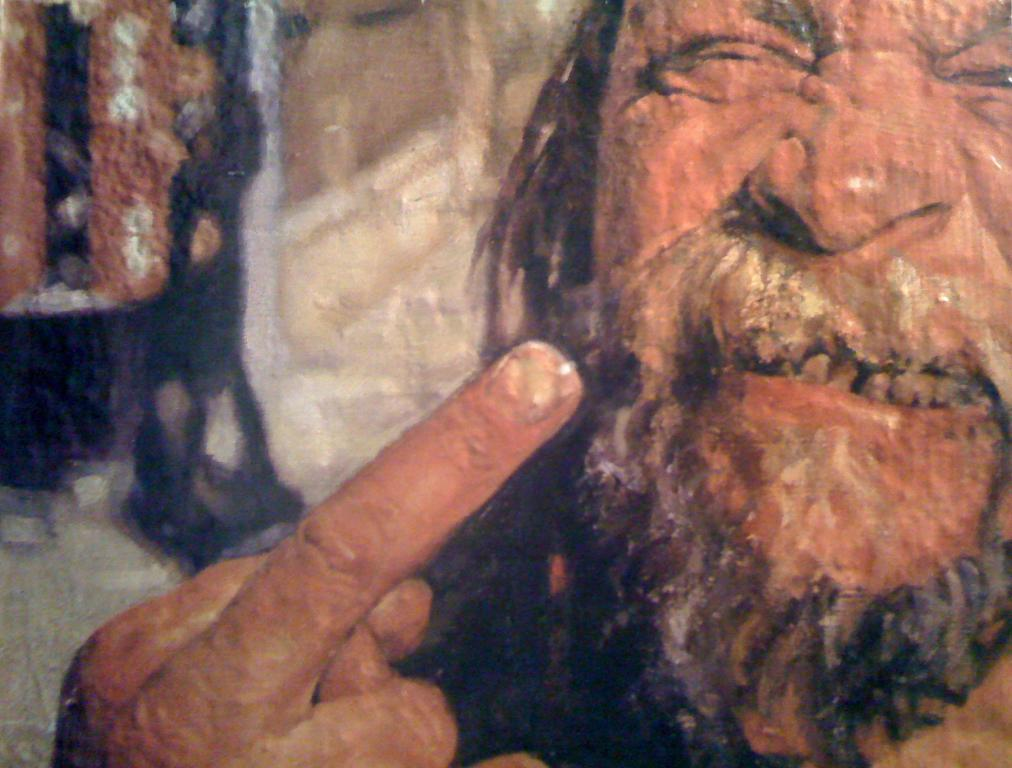What can be seen on the right side of the image? There is a man's face on the right side of the image. What is located on the left side of the image? There is a hand of a person and a woman on the left side of the image. Can you describe the woman in the image? The woman is on the left side of the image. What hobbies does the man in the image enjoy? There is no information about the man's hobbies in the image. What type of trade does the woman in the image participate in? There is no information about the woman's trade in the image. 